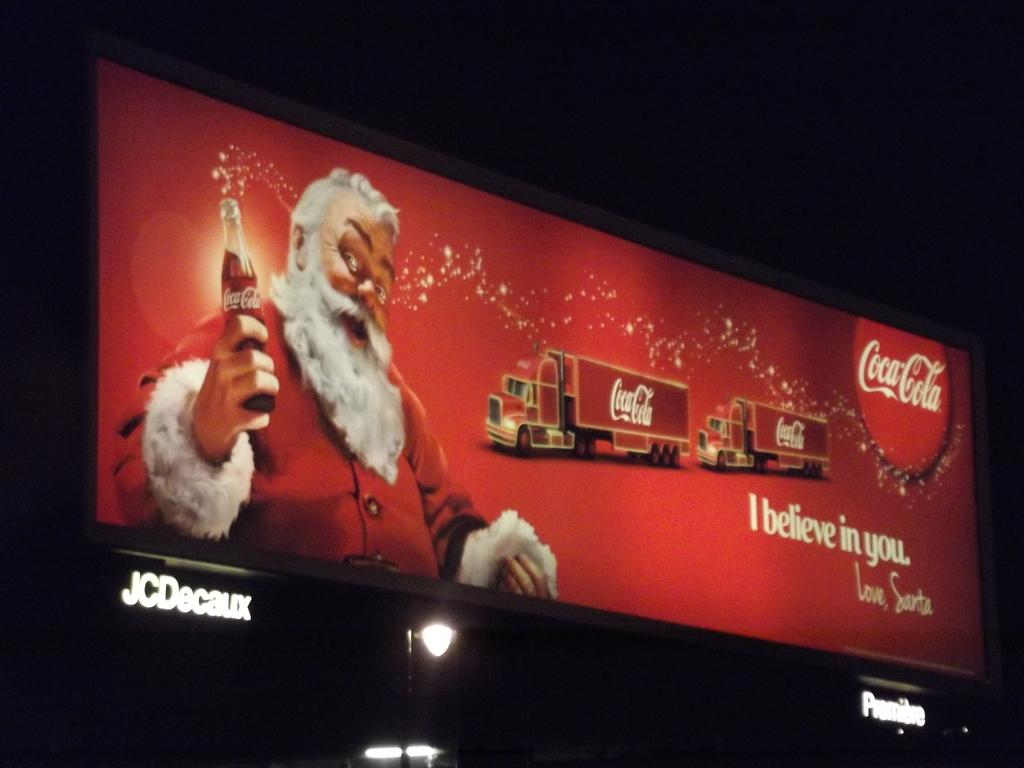<image>
Describe the image concisely. A billboard with Santa saying I believe in you by Coca-Cola. 